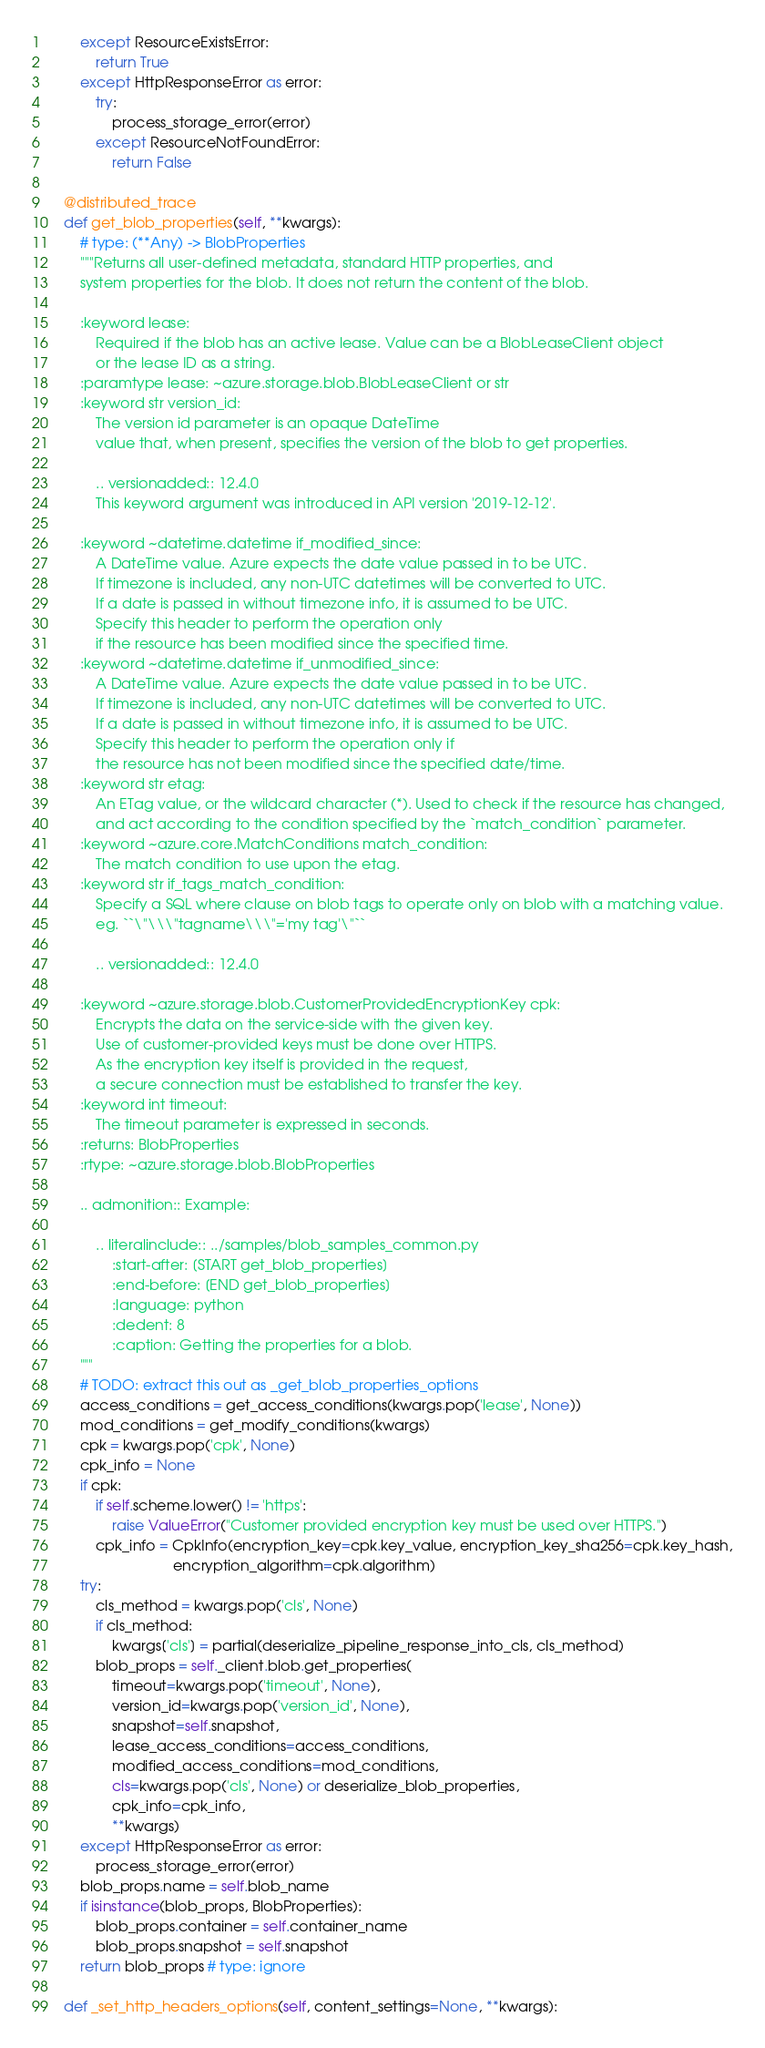<code> <loc_0><loc_0><loc_500><loc_500><_Python_>        except ResourceExistsError:
            return True
        except HttpResponseError as error:
            try:
                process_storage_error(error)
            except ResourceNotFoundError:
                return False

    @distributed_trace
    def get_blob_properties(self, **kwargs):
        # type: (**Any) -> BlobProperties
        """Returns all user-defined metadata, standard HTTP properties, and
        system properties for the blob. It does not return the content of the blob.

        :keyword lease:
            Required if the blob has an active lease. Value can be a BlobLeaseClient object
            or the lease ID as a string.
        :paramtype lease: ~azure.storage.blob.BlobLeaseClient or str
        :keyword str version_id:
            The version id parameter is an opaque DateTime
            value that, when present, specifies the version of the blob to get properties.

            .. versionadded:: 12.4.0
            This keyword argument was introduced in API version '2019-12-12'.

        :keyword ~datetime.datetime if_modified_since:
            A DateTime value. Azure expects the date value passed in to be UTC.
            If timezone is included, any non-UTC datetimes will be converted to UTC.
            If a date is passed in without timezone info, it is assumed to be UTC.
            Specify this header to perform the operation only
            if the resource has been modified since the specified time.
        :keyword ~datetime.datetime if_unmodified_since:
            A DateTime value. Azure expects the date value passed in to be UTC.
            If timezone is included, any non-UTC datetimes will be converted to UTC.
            If a date is passed in without timezone info, it is assumed to be UTC.
            Specify this header to perform the operation only if
            the resource has not been modified since the specified date/time.
        :keyword str etag:
            An ETag value, or the wildcard character (*). Used to check if the resource has changed,
            and act according to the condition specified by the `match_condition` parameter.
        :keyword ~azure.core.MatchConditions match_condition:
            The match condition to use upon the etag.
        :keyword str if_tags_match_condition:
            Specify a SQL where clause on blob tags to operate only on blob with a matching value.
            eg. ``\"\\\"tagname\\\"='my tag'\"``

            .. versionadded:: 12.4.0

        :keyword ~azure.storage.blob.CustomerProvidedEncryptionKey cpk:
            Encrypts the data on the service-side with the given key.
            Use of customer-provided keys must be done over HTTPS.
            As the encryption key itself is provided in the request,
            a secure connection must be established to transfer the key.
        :keyword int timeout:
            The timeout parameter is expressed in seconds.
        :returns: BlobProperties
        :rtype: ~azure.storage.blob.BlobProperties

        .. admonition:: Example:

            .. literalinclude:: ../samples/blob_samples_common.py
                :start-after: [START get_blob_properties]
                :end-before: [END get_blob_properties]
                :language: python
                :dedent: 8
                :caption: Getting the properties for a blob.
        """
        # TODO: extract this out as _get_blob_properties_options
        access_conditions = get_access_conditions(kwargs.pop('lease', None))
        mod_conditions = get_modify_conditions(kwargs)
        cpk = kwargs.pop('cpk', None)
        cpk_info = None
        if cpk:
            if self.scheme.lower() != 'https':
                raise ValueError("Customer provided encryption key must be used over HTTPS.")
            cpk_info = CpkInfo(encryption_key=cpk.key_value, encryption_key_sha256=cpk.key_hash,
                               encryption_algorithm=cpk.algorithm)
        try:
            cls_method = kwargs.pop('cls', None)
            if cls_method:
                kwargs['cls'] = partial(deserialize_pipeline_response_into_cls, cls_method)
            blob_props = self._client.blob.get_properties(
                timeout=kwargs.pop('timeout', None),
                version_id=kwargs.pop('version_id', None),
                snapshot=self.snapshot,
                lease_access_conditions=access_conditions,
                modified_access_conditions=mod_conditions,
                cls=kwargs.pop('cls', None) or deserialize_blob_properties,
                cpk_info=cpk_info,
                **kwargs)
        except HttpResponseError as error:
            process_storage_error(error)
        blob_props.name = self.blob_name
        if isinstance(blob_props, BlobProperties):
            blob_props.container = self.container_name
            blob_props.snapshot = self.snapshot
        return blob_props # type: ignore

    def _set_http_headers_options(self, content_settings=None, **kwargs):</code> 